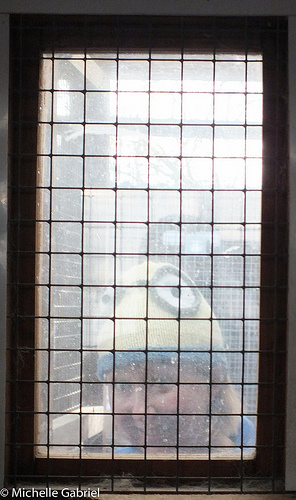<image>
Is there a wires behind the lady? No. The wires is not behind the lady. From this viewpoint, the wires appears to be positioned elsewhere in the scene. 